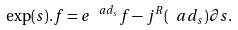<formula> <loc_0><loc_0><loc_500><loc_500>\exp ( s ) . f = e ^ { \ a d _ { s } } f - j ^ { R } ( \ a d _ { s } ) \partial s .</formula> 